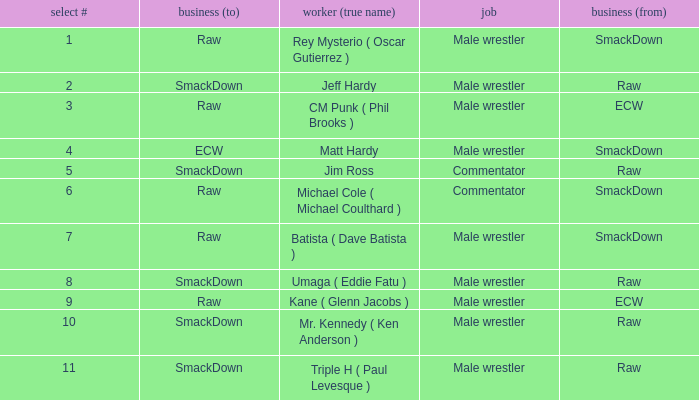What is the real name of the male wrestler from Raw with a pick # smaller than 6? Jeff Hardy. 